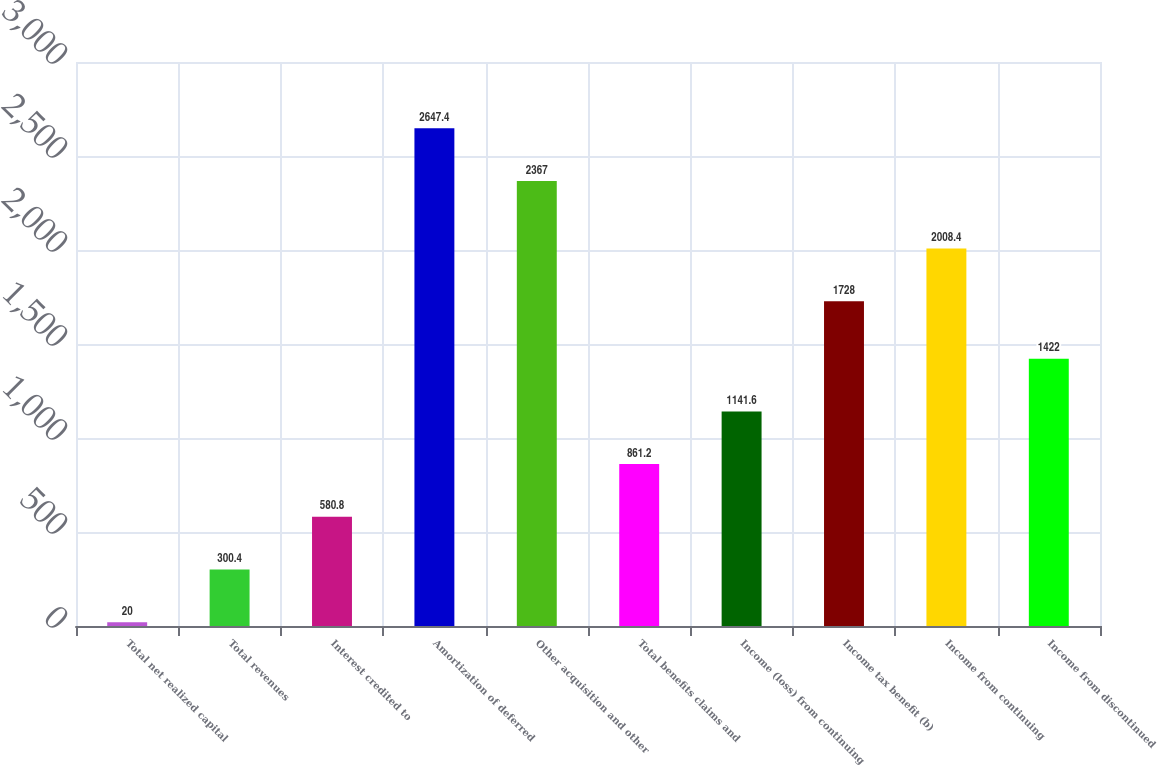Convert chart to OTSL. <chart><loc_0><loc_0><loc_500><loc_500><bar_chart><fcel>Total net realized capital<fcel>Total revenues<fcel>Interest credited to<fcel>Amortization of deferred<fcel>Other acquisition and other<fcel>Total benefits claims and<fcel>Income (loss) from continuing<fcel>Income tax benefit (b)<fcel>Income from continuing<fcel>Income from discontinued<nl><fcel>20<fcel>300.4<fcel>580.8<fcel>2647.4<fcel>2367<fcel>861.2<fcel>1141.6<fcel>1728<fcel>2008.4<fcel>1422<nl></chart> 